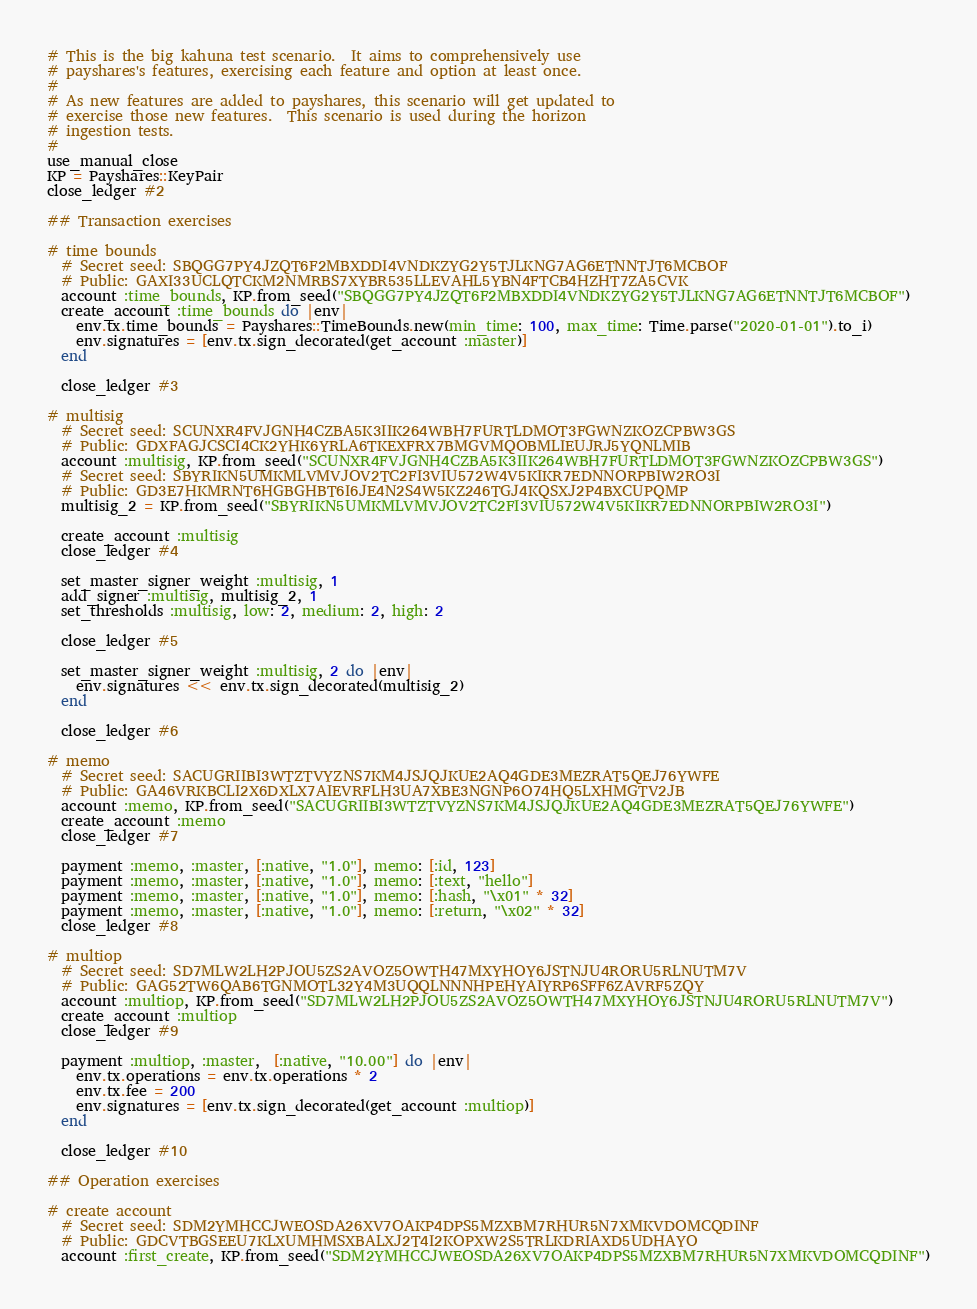Convert code to text. <code><loc_0><loc_0><loc_500><loc_500><_Ruby_># This is the big kahuna test scenario.  It aims to comprehensively use
# payshares's features, exercising each feature and option at least once.
#
# As new features are added to payshares, this scenario will get updated to
# exercise those new features.  This scenario is used during the horizon
# ingestion tests.
#
use_manual_close
KP = Payshares::KeyPair
close_ledger #2

## Transaction exercises

# time bounds
  # Secret seed: SBQGG7PY4JZQT6F2MBXDDI4VNDKZYG2Y5TJLKNG7AG6ETNNTJT6MCBOF
  # Public: GAXI33UCLQTCKM2NMRBS7XYBR535LLEVAHL5YBN4FTCB4HZHT7ZA5CVK
  account :time_bounds, KP.from_seed("SBQGG7PY4JZQT6F2MBXDDI4VNDKZYG2Y5TJLKNG7AG6ETNNTJT6MCBOF")
  create_account :time_bounds do |env|
    env.tx.time_bounds = Payshares::TimeBounds.new(min_time: 100, max_time: Time.parse("2020-01-01").to_i)
    env.signatures = [env.tx.sign_decorated(get_account :master)]
  end

  close_ledger #3

# multisig
  # Secret seed: SCUNXR4FVJGNH4CZBA5K3IIK264WBH7FURTLDMOT3FGWNZKOZCPBW3GS
  # Public: GDXFAGJCSCI4CK2YHK6YRLA6TKEXFRX7BMGVMQOBMLIEUJRJ5YQNLMIB
  account :multisig, KP.from_seed("SCUNXR4FVJGNH4CZBA5K3IIK264WBH7FURTLDMOT3FGWNZKOZCPBW3GS")
  # Secret seed: SBYRIKN5UMKMLVMVJOV2TC2FI3VIU572W4V5KIKR7EDNNORPBIW2RO3I
  # Public: GD3E7HKMRNT6HGBGHBT6I6JE4N2S4W5KZ246TGJ4KQSXJ2P4BXCUPQMP
  multisig_2 = KP.from_seed("SBYRIKN5UMKMLVMVJOV2TC2FI3VIU572W4V5KIKR7EDNNORPBIW2RO3I")

  create_account :multisig
  close_ledger #4

  set_master_signer_weight :multisig, 1
  add_signer :multisig, multisig_2, 1
  set_thresholds :multisig, low: 2, medium: 2, high: 2

  close_ledger #5

  set_master_signer_weight :multisig, 2 do |env|
    env.signatures << env.tx.sign_decorated(multisig_2)
  end

  close_ledger #6

# memo
  # Secret seed: SACUGRIIBI3WTZTVYZNS7KM4JSJQJKUE2AQ4GDE3MEZRAT5QEJ76YWFE
  # Public: GA46VRKBCLI2X6DXLX7AIEVRFLH3UA7XBE3NGNP6O74HQ5LXHMGTV2JB
  account :memo, KP.from_seed("SACUGRIIBI3WTZTVYZNS7KM4JSJQJKUE2AQ4GDE3MEZRAT5QEJ76YWFE")
  create_account :memo
  close_ledger #7

  payment :memo, :master, [:native, "1.0"], memo: [:id, 123]
  payment :memo, :master, [:native, "1.0"], memo: [:text, "hello"]
  payment :memo, :master, [:native, "1.0"], memo: [:hash, "\x01" * 32]
  payment :memo, :master, [:native, "1.0"], memo: [:return, "\x02" * 32]
  close_ledger #8

# multiop
  # Secret seed: SD7MLW2LH2PJOU5ZS2AVOZ5OWTH47MXYHOY6JSTNJU4RORU5RLNUTM7V
  # Public: GAG52TW6QAB6TGNMOTL32Y4M3UQQLNNNHPEHYAIYRP6SFF6ZAVRF5ZQY
  account :multiop, KP.from_seed("SD7MLW2LH2PJOU5ZS2AVOZ5OWTH47MXYHOY6JSTNJU4RORU5RLNUTM7V")
  create_account :multiop
  close_ledger #9

  payment :multiop, :master,  [:native, "10.00"] do |env|
    env.tx.operations = env.tx.operations * 2
    env.tx.fee = 200
    env.signatures = [env.tx.sign_decorated(get_account :multiop)]
  end

  close_ledger #10

## Operation exercises

# create account
  # Secret seed: SDM2YMHCCJWEOSDA26XV7OAKP4DPS5MZXBM7RHUR5N7XMKVDOMCQDINF
  # Public: GDCVTBGSEEU7KLXUMHMSXBALXJ2T4I2KOPXW2S5TRLKDRIAXD5UDHAYO
  account :first_create, KP.from_seed("SDM2YMHCCJWEOSDA26XV7OAKP4DPS5MZXBM7RHUR5N7XMKVDOMCQDINF")</code> 